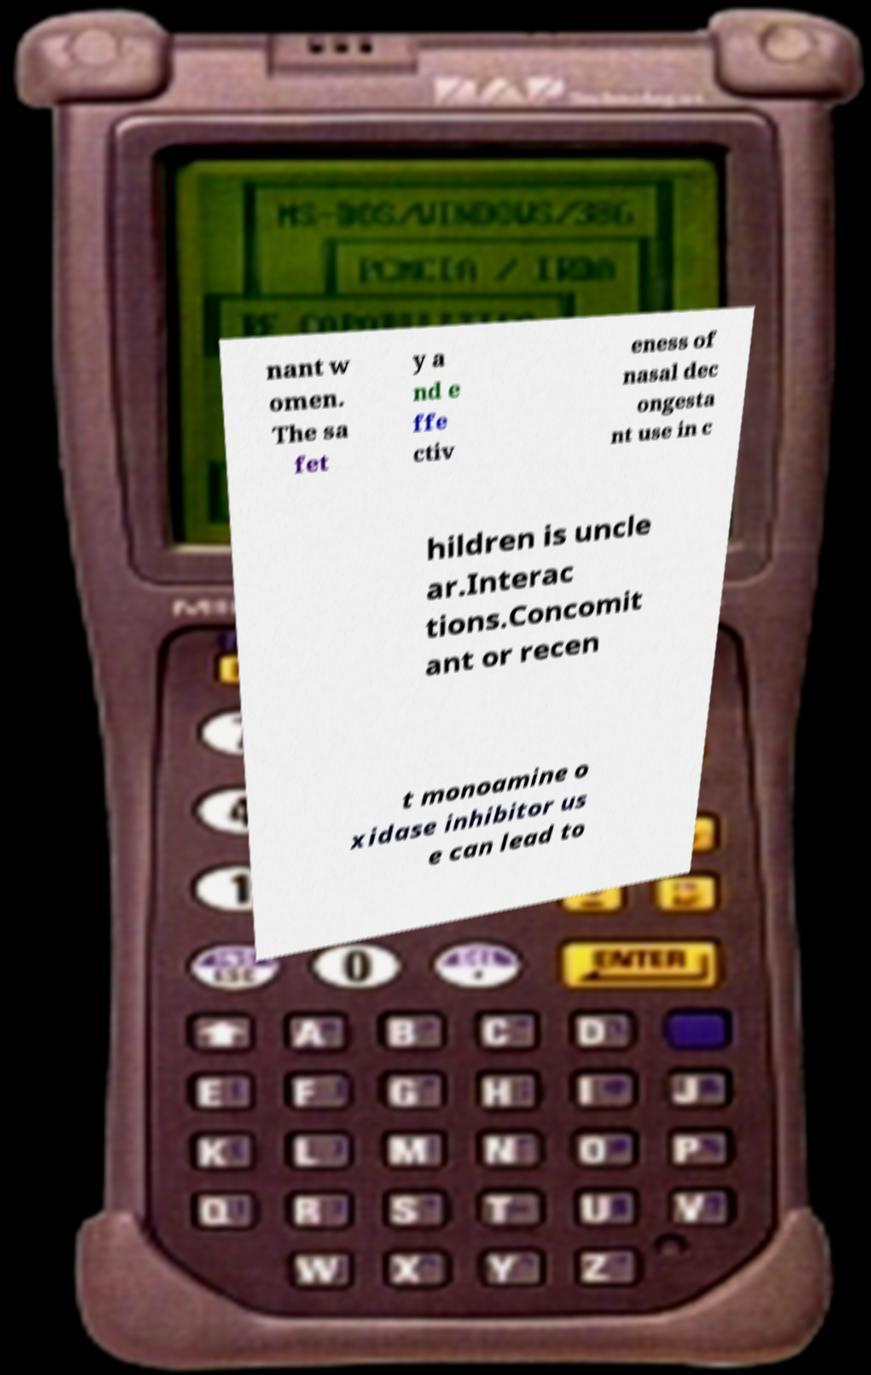Could you extract and type out the text from this image? nant w omen. The sa fet y a nd e ffe ctiv eness of nasal dec ongesta nt use in c hildren is uncle ar.Interac tions.Concomit ant or recen t monoamine o xidase inhibitor us e can lead to 